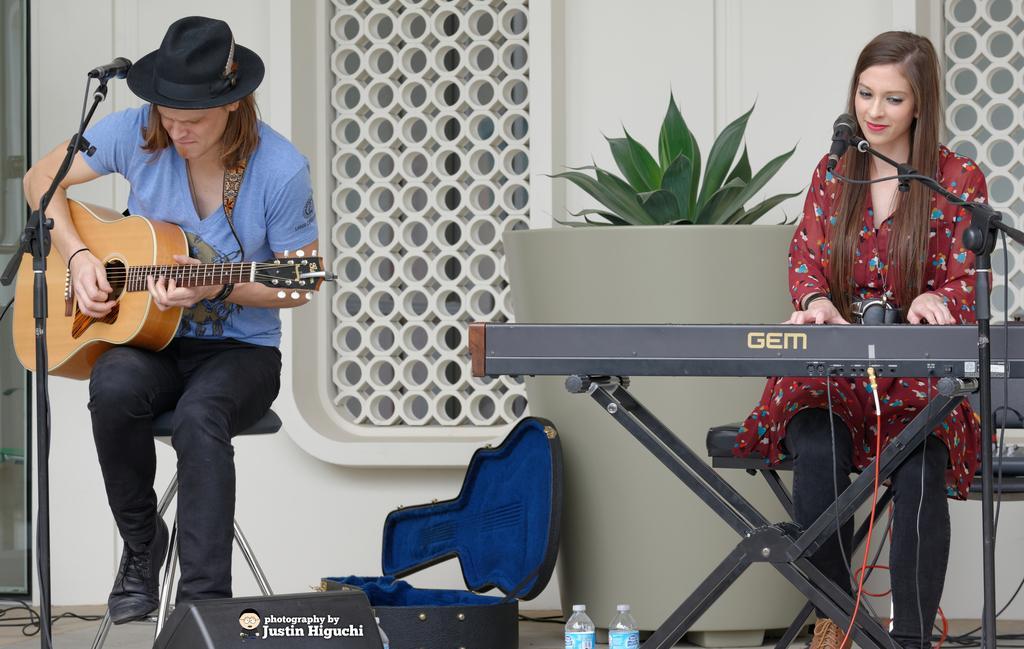Please provide a concise description of this image. In this image there are two persons. At the left side of the image there is a person wearing blue color T-shirt and black color hat playing a guitar in front of him there is a microphone and at the right side of the image there is a lady person wearing red color dress playing piano and in front of her there is a microphone. 